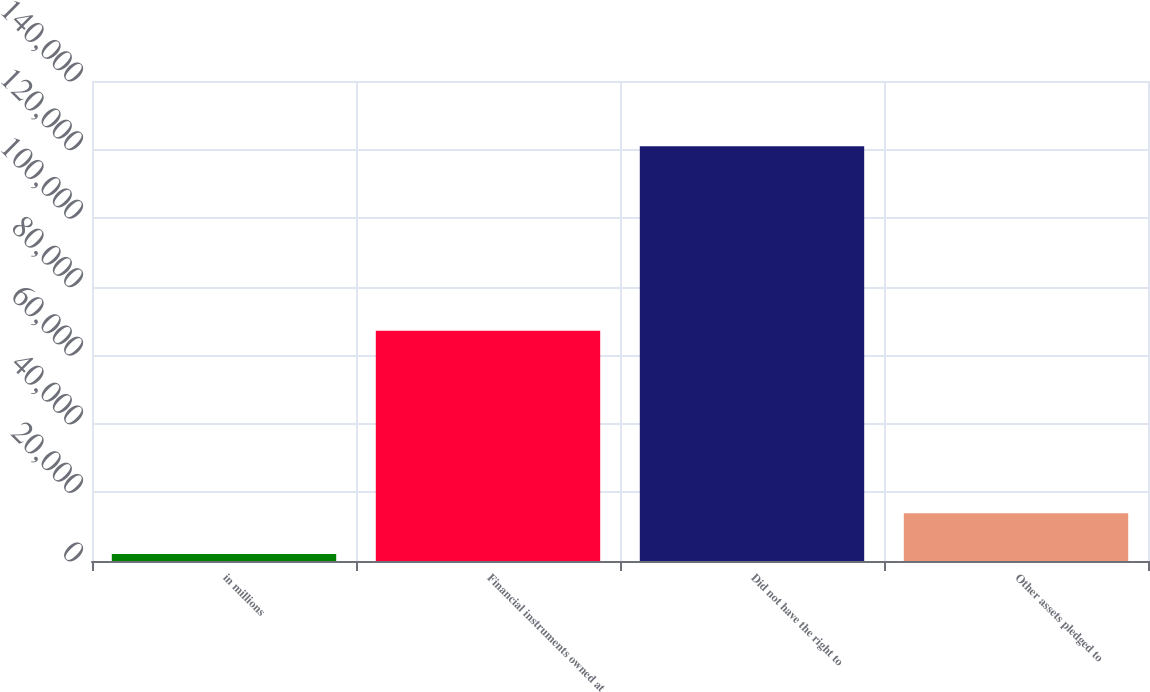Convert chart. <chart><loc_0><loc_0><loc_500><loc_500><bar_chart><fcel>in millions<fcel>Financial instruments owned at<fcel>Did not have the right to<fcel>Other assets pledged to<nl><fcel>2012<fcel>67177<fcel>120980<fcel>13908.8<nl></chart> 